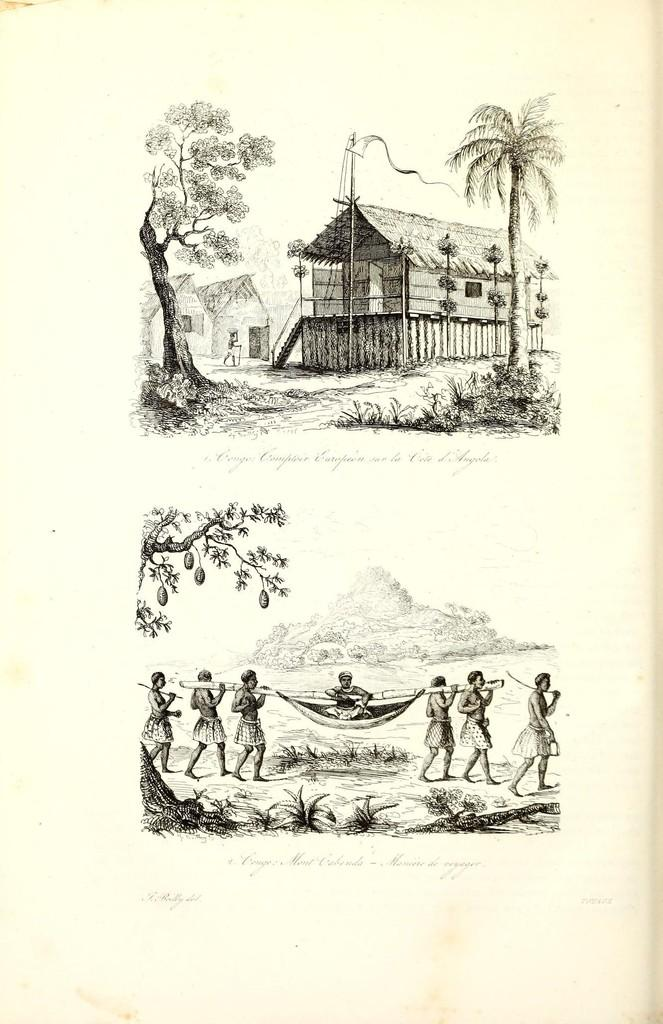How many pictures can be seen in the image? There are two pictures in the image. What is happening at the bottom of the image? At the bottom of the image, there are people walking. What type of structures are visible at the top of the image? At the top of the image, there are homes. What type of natural elements can be seen in the image? There are trees visible in the image. How do the people in the image rub the trees? There is no indication in the image that the people are rubbing the trees; they are simply walking. 